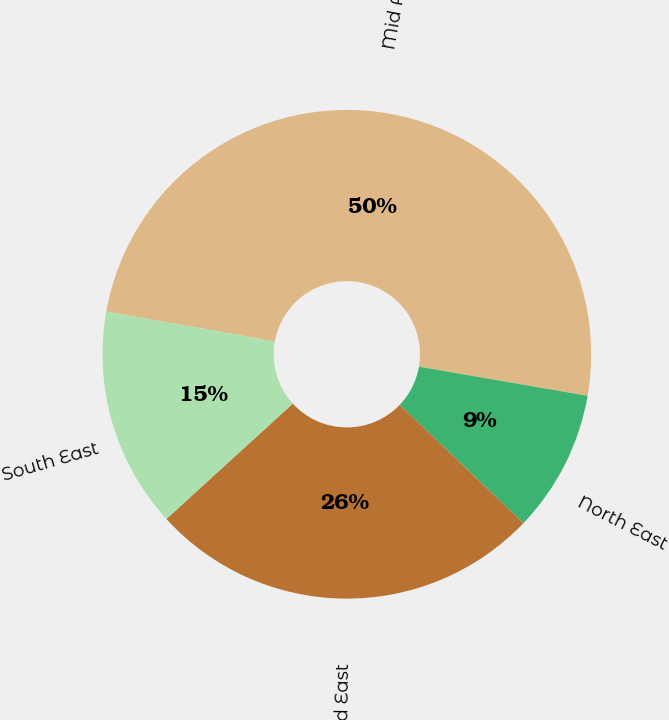<chart> <loc_0><loc_0><loc_500><loc_500><pie_chart><fcel>Mid Atlantic<fcel>North East<fcel>Mid East<fcel>South East<nl><fcel>49.92%<fcel>9.43%<fcel>26.08%<fcel>14.57%<nl></chart> 